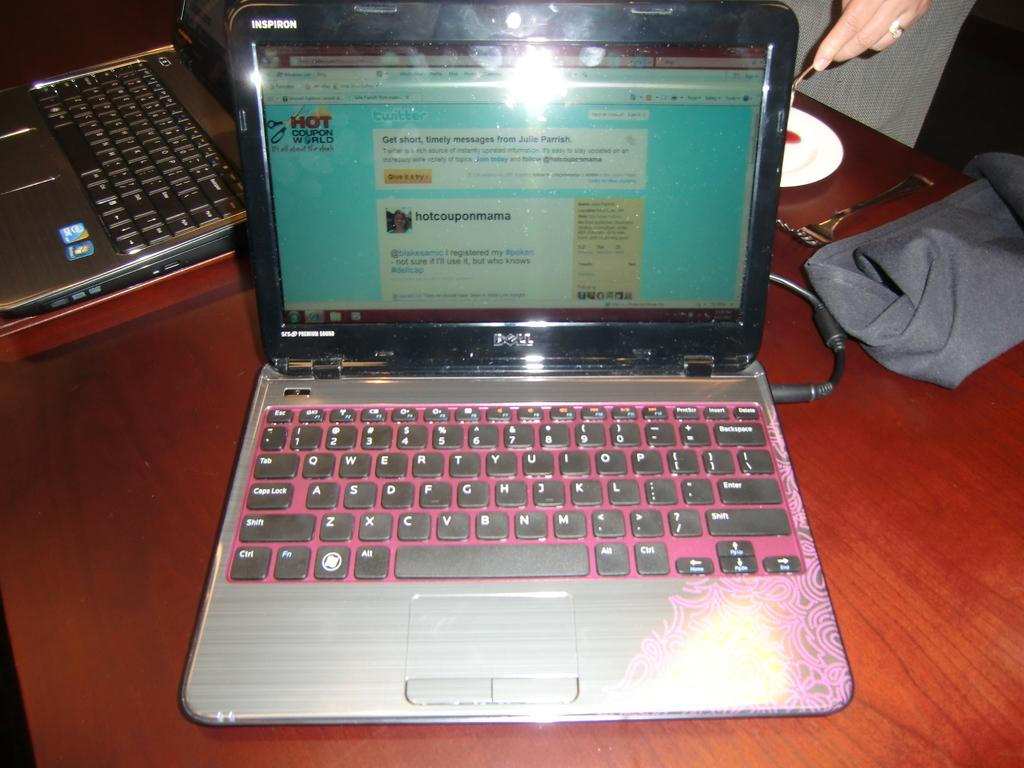<image>
Create a compact narrative representing the image presented. An old dell laptop sitting on top of a wood table 